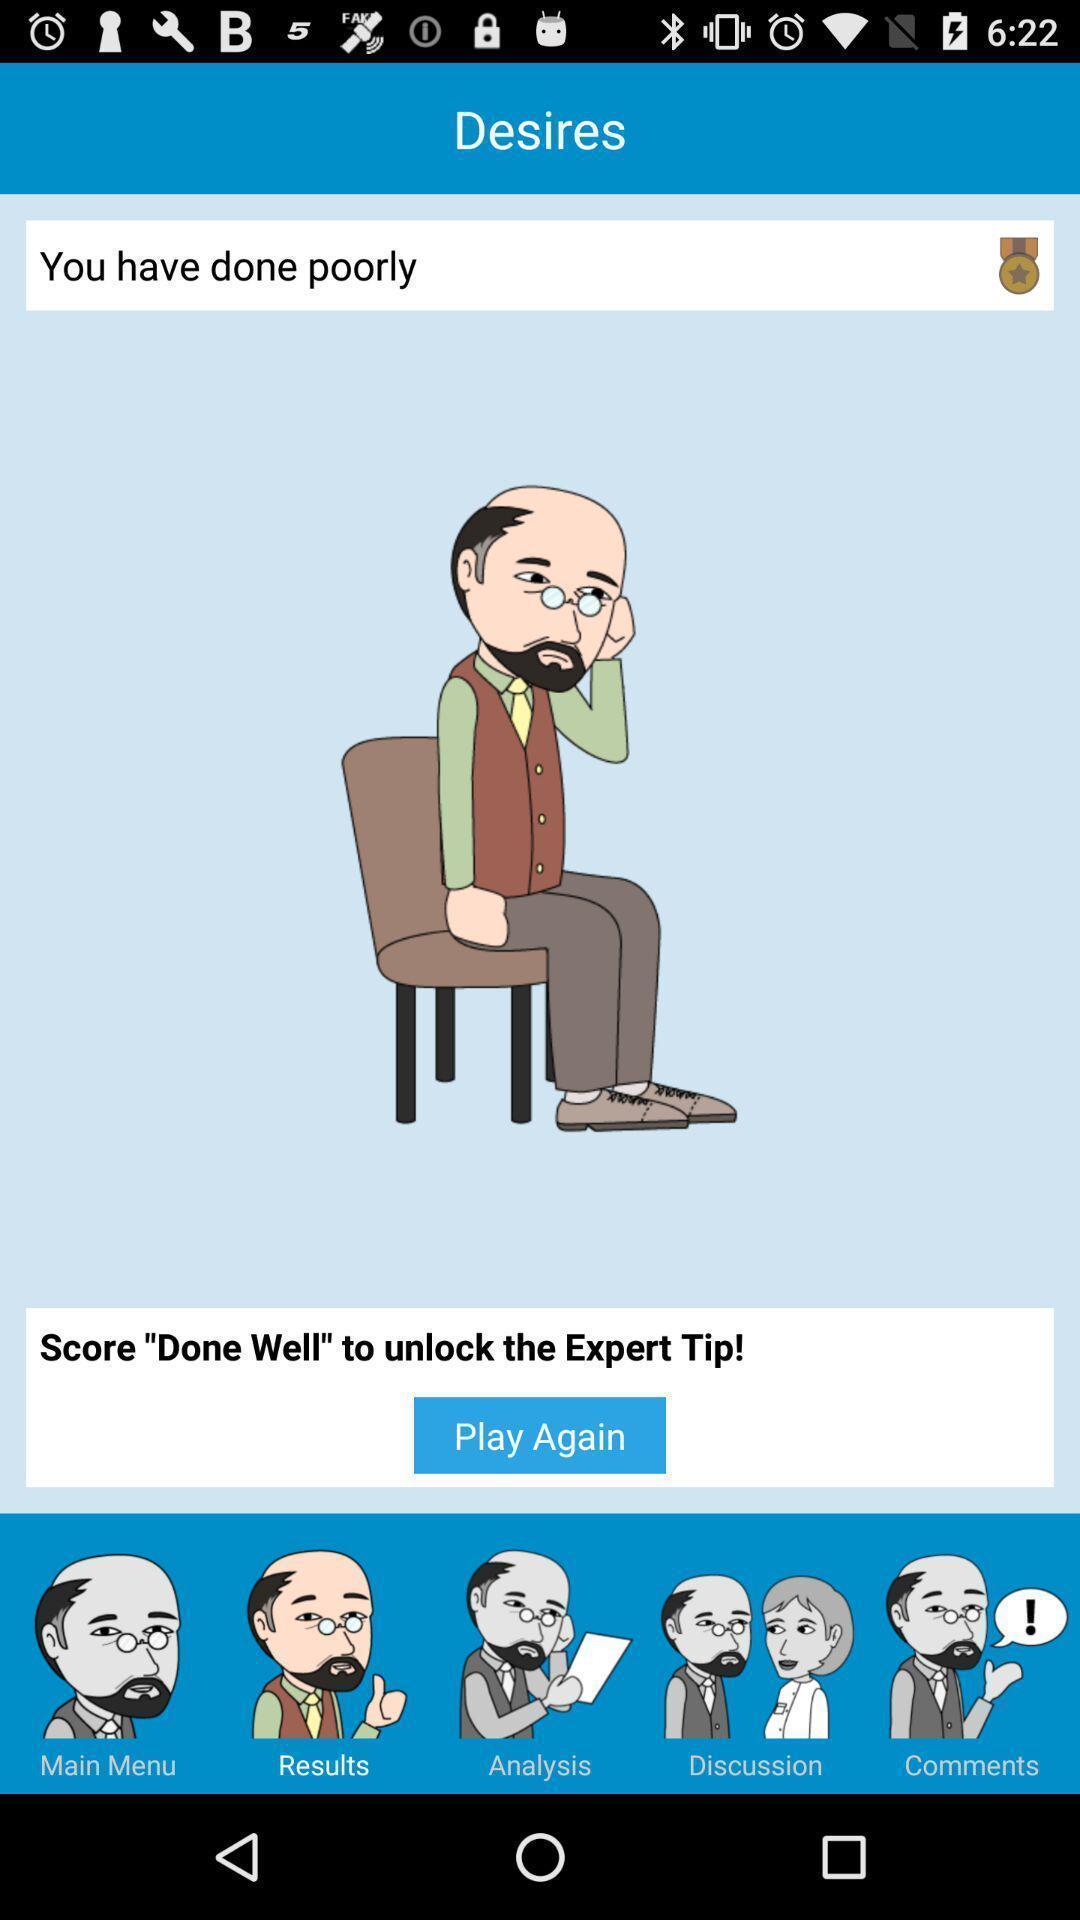Summarize the main components in this picture. Sticker on the relevant search. 